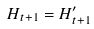<formula> <loc_0><loc_0><loc_500><loc_500>H _ { t + 1 } = H _ { t + 1 } ^ { \prime }</formula> 